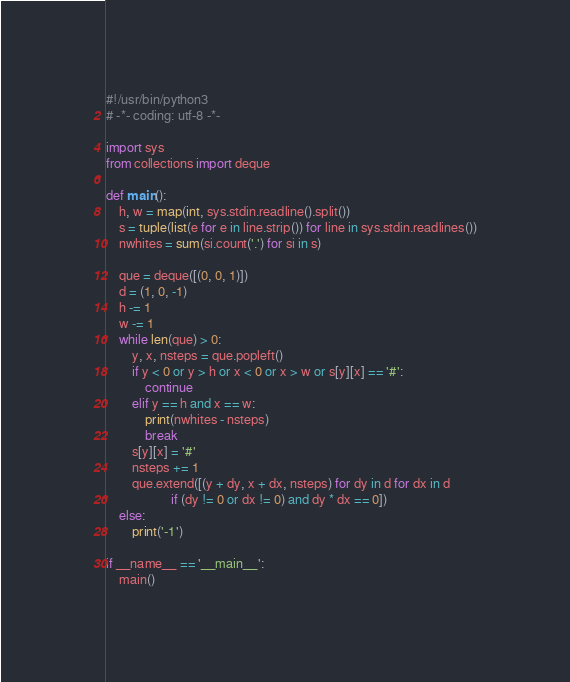Convert code to text. <code><loc_0><loc_0><loc_500><loc_500><_Python_>#!/usr/bin/python3
# -*- coding: utf-8 -*-

import sys
from collections import deque

def main():
    h, w = map(int, sys.stdin.readline().split())
    s = tuple(list(e for e in line.strip()) for line in sys.stdin.readlines())
    nwhites = sum(si.count('.') for si in s)

    que = deque([(0, 0, 1)])
    d = (1, 0, -1)
    h -= 1
    w -= 1
    while len(que) > 0:
        y, x, nsteps = que.popleft()
        if y < 0 or y > h or x < 0 or x > w or s[y][x] == '#':
            continue
        elif y == h and x == w:
            print(nwhites - nsteps)
            break
        s[y][x] = '#'
        nsteps += 1
        que.extend([(y + dy, x + dx, nsteps) for dy in d for dx in d
                    if (dy != 0 or dx != 0) and dy * dx == 0])
    else:
        print('-1')

if __name__ == '__main__':
    main()
</code> 